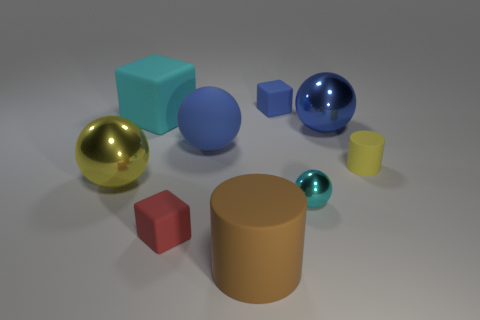Subtract all cubes. How many objects are left? 6 Subtract 0 gray balls. How many objects are left? 9 Subtract all blue metal spheres. Subtract all large matte things. How many objects are left? 5 Add 3 tiny red things. How many tiny red things are left? 4 Add 4 matte cylinders. How many matte cylinders exist? 6 